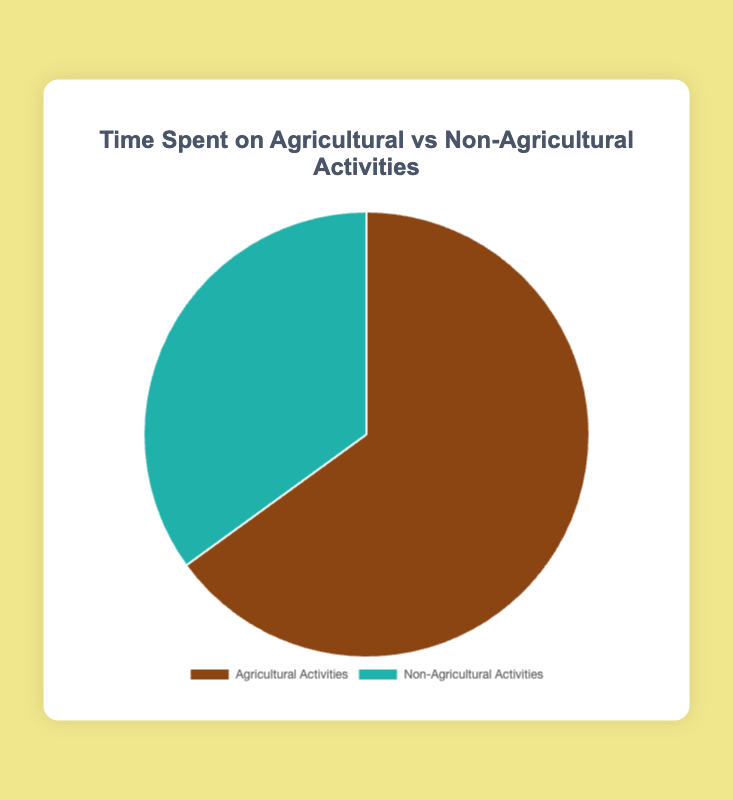What percentage of time is spent on agricultural activities? The chart shows that 65% of the time is spent on agricultural activities. Simply look at the slice labeled "Agricultural Activities" to determine the percentage.
Answer: 65% Compare the time percentage spent on agricultural activities with non-agricultural activities. Which one is higher? The chart displays two slices labeled "Agricultural Activities" (65%) and "Non-Agricultural Activities" (35%). 65% is greater than 35%, so more time is spent on agricultural activities.
Answer: Agricultural Activities Calculate the difference in time percentage between agricultural and non-agricultural activities. Subtract the percentage of time spent on non-agricultural activities (35%) from the time spent on agricultural activities (65%). This gives 65% - 35% = 30%.
Answer: 30% What has a smaller share of the pie chart, agricultural or non-agricultural activities? By examining the chart, we see that "Non-Agricultural Activities" has a smaller slice accounting for 35% compared to 65% for "Agricultural Activities".
Answer: Non-Agricultural Activities Which activities are represented by the color brown in the chart? The chart legend indicates that "Agricultural Activities" is represented by the brown color.
Answer: Agricultural Activities If both categories were equal, what would be the percentage for each? In a pie chart with two equal categories, each category would be 50%.
Answer: 50% What is the combined total percentage of time spent on all activities? The entire pie chart represents 100% of the time spent on all activities. Each category contributes a part of this total.
Answer: 100% Calculate the ratio of time spent on agricultural activities to non-agricultural activities. Divide the percentage of time spent on agricultural activities (65%) by the time spent on non-agricultural activities (35%). The ratio is 65:35, which simplifies to 13:7.
Answer: 13:7 If the time percentage for non-agricultural activities increased by 10%, what would be the new percentage for agricultural activities? Start by increasing the non-agricultural activities’ percentage from 35% to 45%. Subtract this from the total 100% to find the new agricultural percentage: 100% - 45% = 55%.
Answer: 55% Which activity has a lighter color in the pie chart? The chart shows that "Non-Agricultural Activities" is represented by a lighter color, light blue, compared to the brown color of "Agricultural Activities".
Answer: Non-Agricultural Activities 